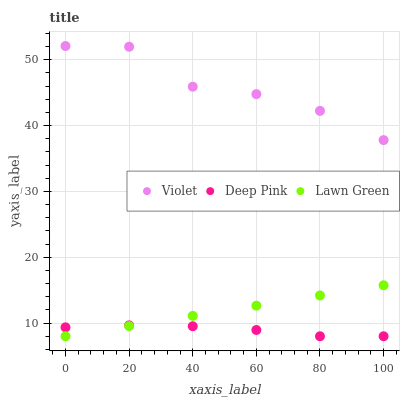Does Deep Pink have the minimum area under the curve?
Answer yes or no. Yes. Does Violet have the maximum area under the curve?
Answer yes or no. Yes. Does Violet have the minimum area under the curve?
Answer yes or no. No. Does Deep Pink have the maximum area under the curve?
Answer yes or no. No. Is Lawn Green the smoothest?
Answer yes or no. Yes. Is Violet the roughest?
Answer yes or no. Yes. Is Deep Pink the smoothest?
Answer yes or no. No. Is Deep Pink the roughest?
Answer yes or no. No. Does Lawn Green have the lowest value?
Answer yes or no. Yes. Does Violet have the lowest value?
Answer yes or no. No. Does Violet have the highest value?
Answer yes or no. Yes. Does Deep Pink have the highest value?
Answer yes or no. No. Is Deep Pink less than Violet?
Answer yes or no. Yes. Is Violet greater than Deep Pink?
Answer yes or no. Yes. Does Deep Pink intersect Lawn Green?
Answer yes or no. Yes. Is Deep Pink less than Lawn Green?
Answer yes or no. No. Is Deep Pink greater than Lawn Green?
Answer yes or no. No. Does Deep Pink intersect Violet?
Answer yes or no. No. 